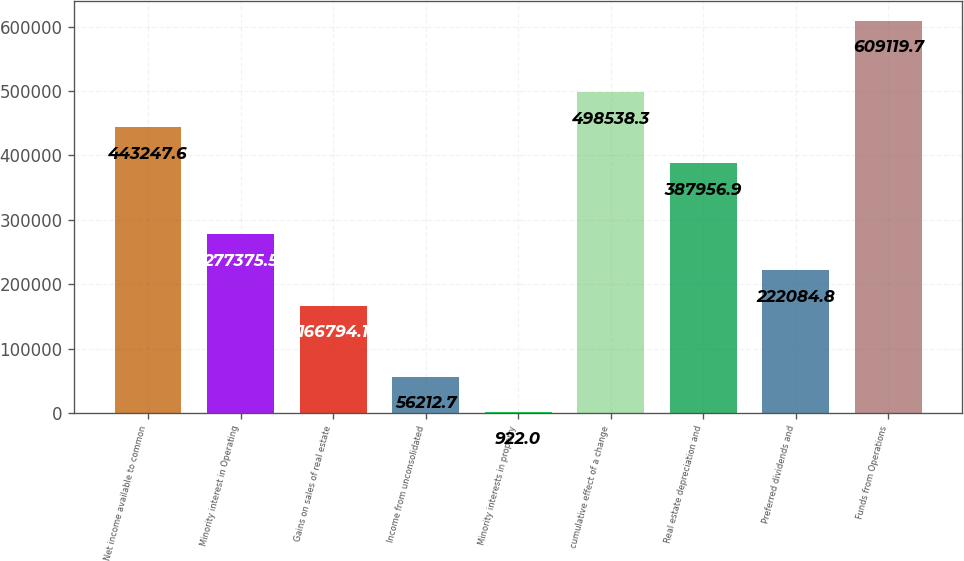Convert chart. <chart><loc_0><loc_0><loc_500><loc_500><bar_chart><fcel>Net income available to common<fcel>Minority interest in Operating<fcel>Gains on sales of real estate<fcel>Income from unconsolidated<fcel>Minority interests in property<fcel>cumulative effect of a change<fcel>Real estate depreciation and<fcel>Preferred dividends and<fcel>Funds from Operations<nl><fcel>443248<fcel>277376<fcel>166794<fcel>56212.7<fcel>922<fcel>498538<fcel>387957<fcel>222085<fcel>609120<nl></chart> 